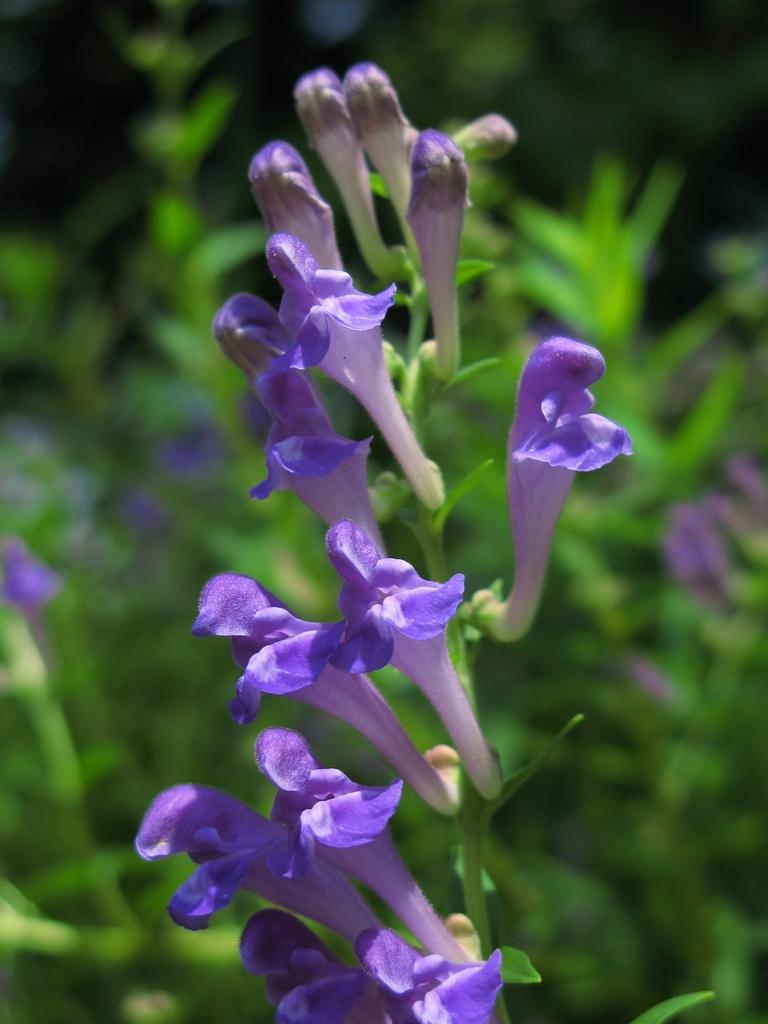What type of flora can be seen in the image? There are flowers in the image. How would you describe the background of the image? The background of the image is blurred. What other natural elements are visible in the image? There is greenery visible in the image. How many dresses can be seen on the donkey in the image? There are no dresses or donkeys present in the image; it features flowers and greenery. What type of frogs are hopping around the flowers in the image? There are no frogs present in the image; it only features flowers and greenery. 